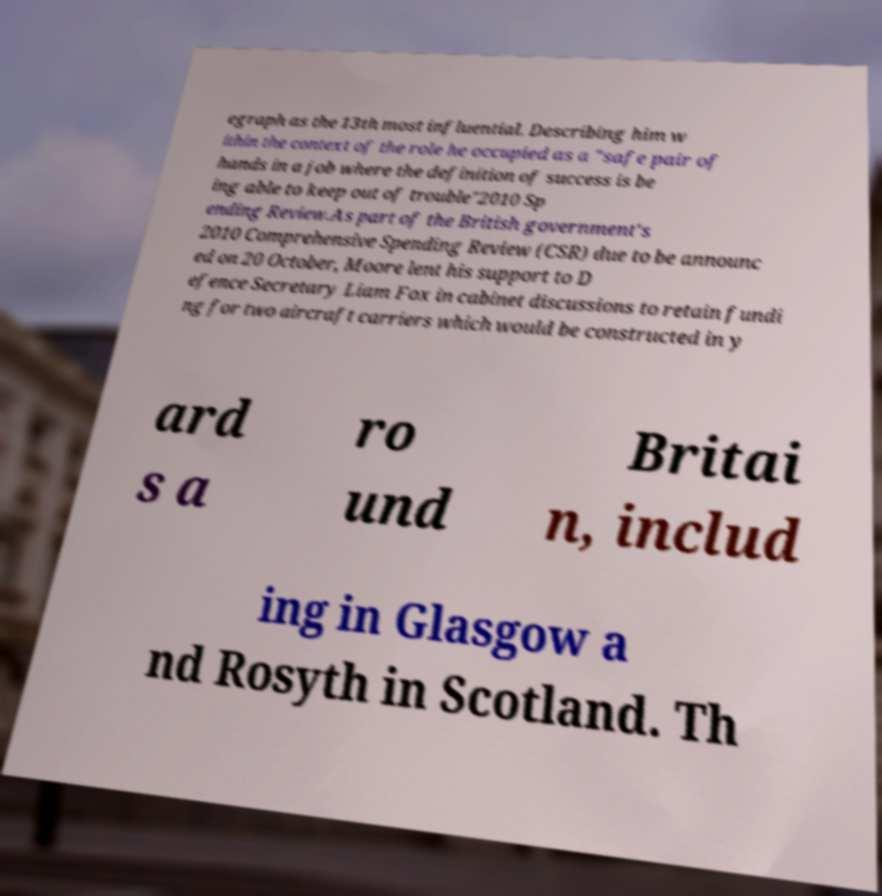Could you assist in decoding the text presented in this image and type it out clearly? egraph as the 13th most influential. Describing him w ithin the context of the role he occupied as a "safe pair of hands in a job where the definition of success is be ing able to keep out of trouble"2010 Sp ending Review.As part of the British government's 2010 Comprehensive Spending Review (CSR) due to be announc ed on 20 October, Moore lent his support to D efence Secretary Liam Fox in cabinet discussions to retain fundi ng for two aircraft carriers which would be constructed in y ard s a ro und Britai n, includ ing in Glasgow a nd Rosyth in Scotland. Th 